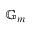<formula> <loc_0><loc_0><loc_500><loc_500>\mathbb { G } _ { m }</formula> 